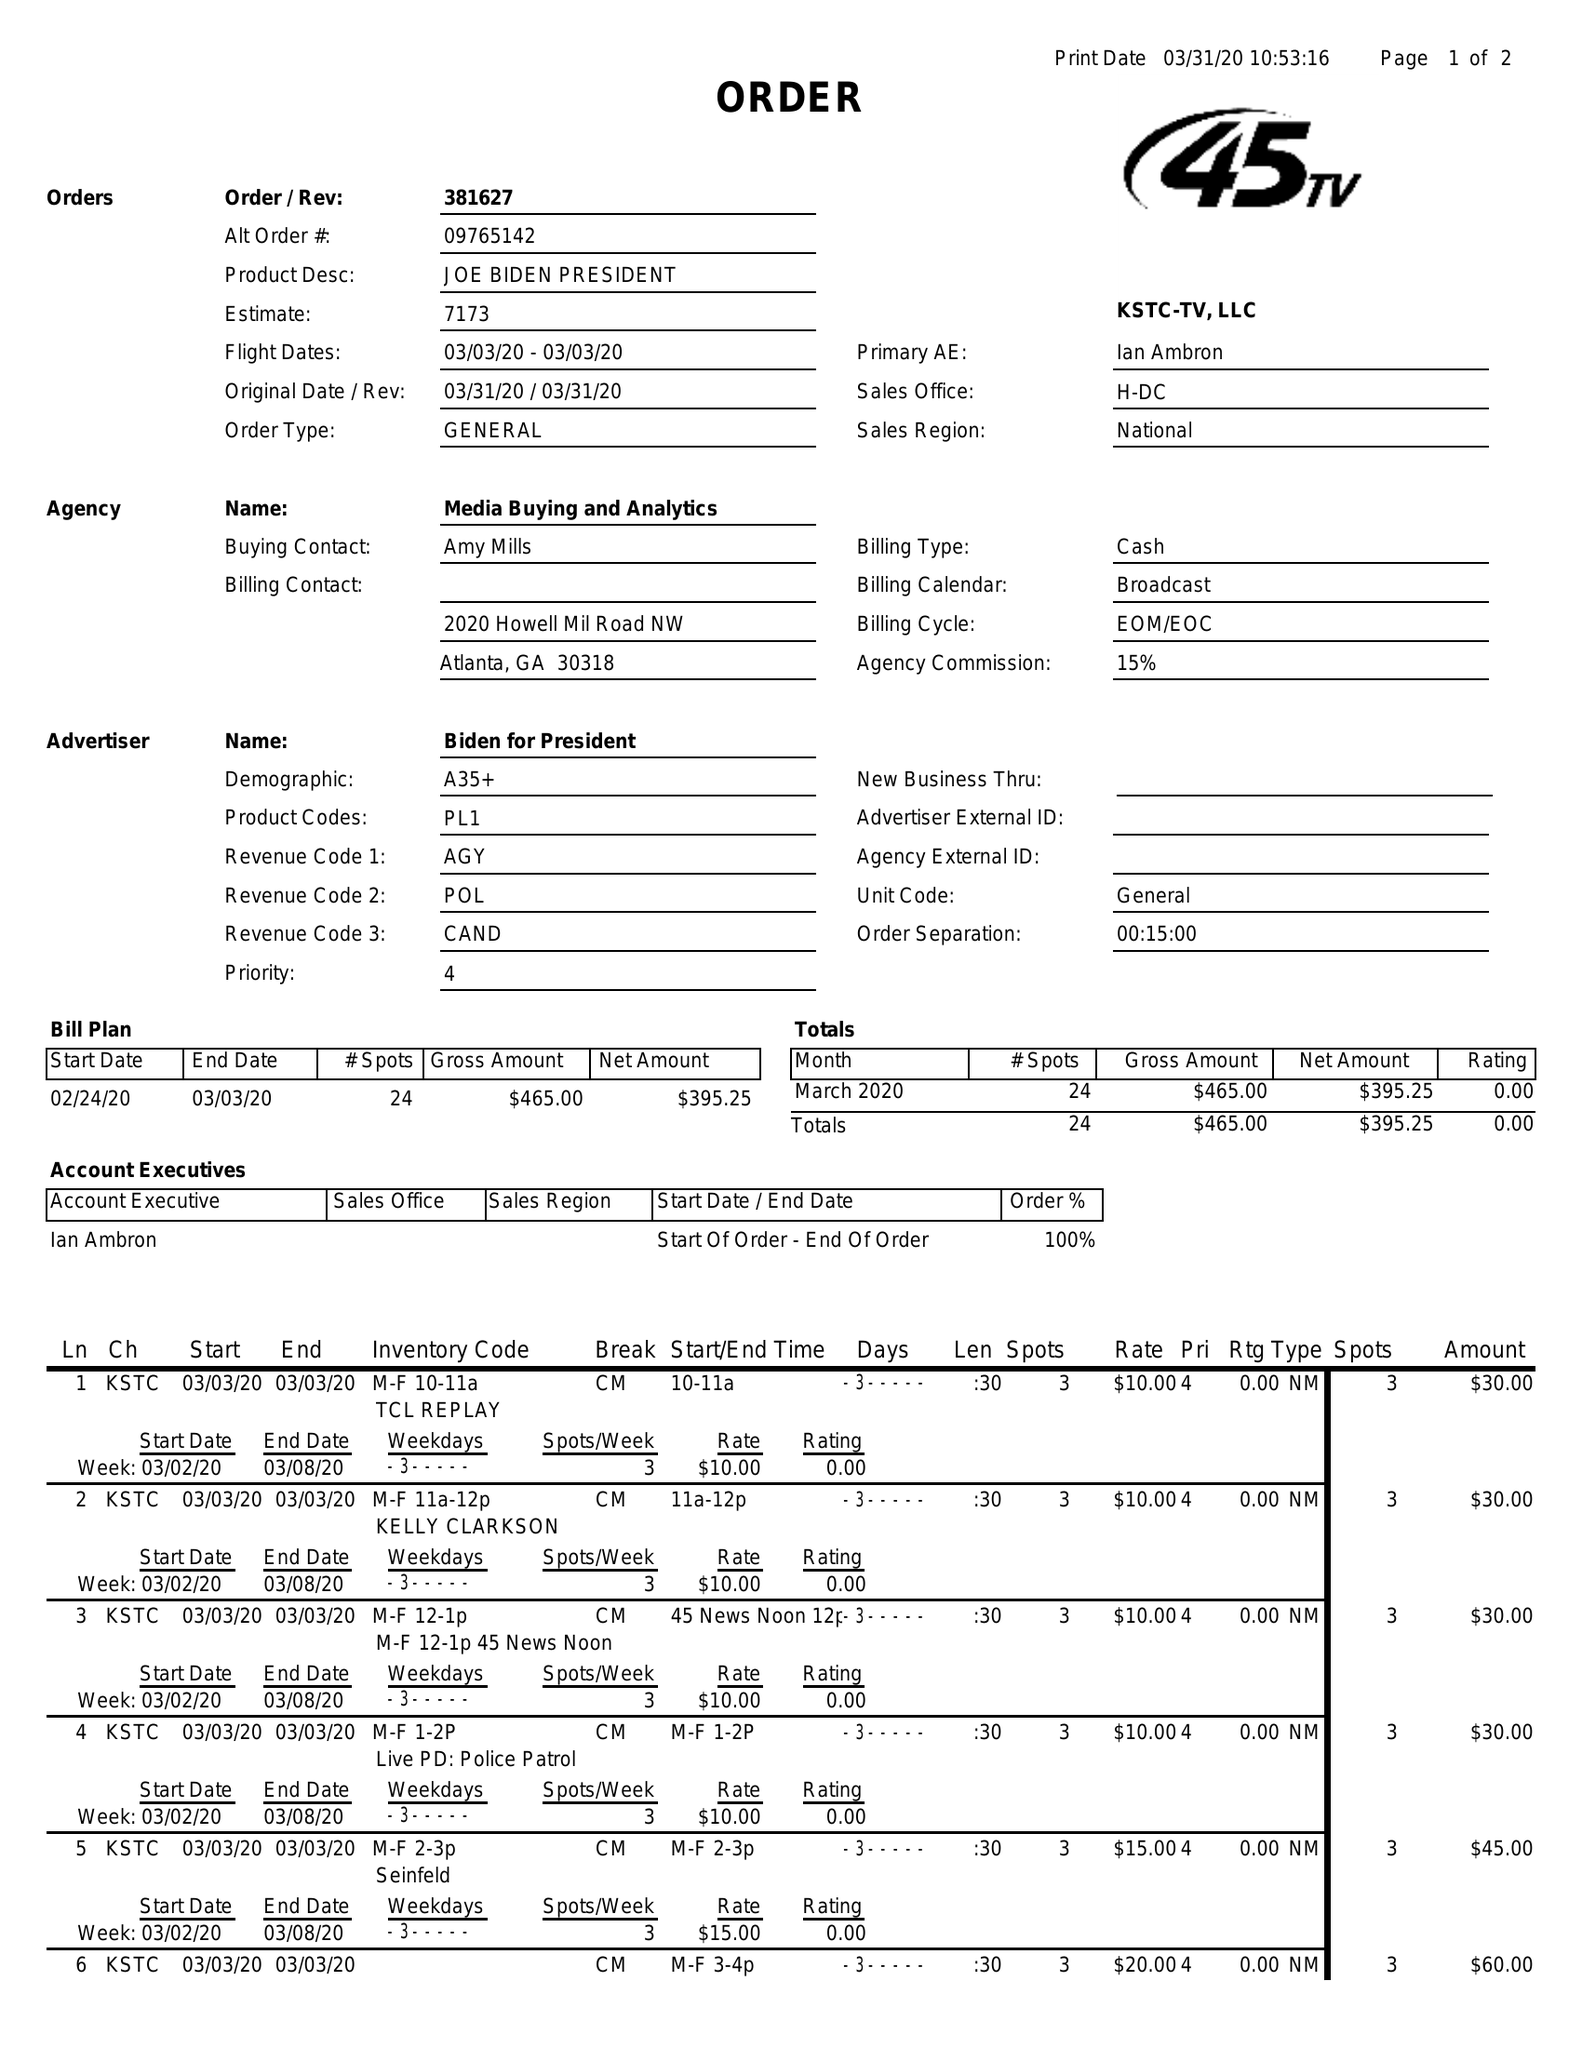What is the value for the flight_to?
Answer the question using a single word or phrase. 03/03/20 